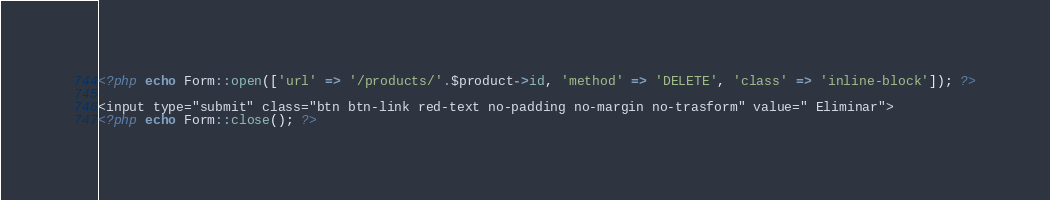Convert code to text. <code><loc_0><loc_0><loc_500><loc_500><_PHP_><?php echo Form::open(['url' => '/products/'.$product->id, 'method' => 'DELETE', 'class' => 'inline-block']); ?>

<input type="submit" class="btn btn-link red-text no-padding no-margin no-trasform" value=" Eliminar">
<?php echo Form::close(); ?> </code> 